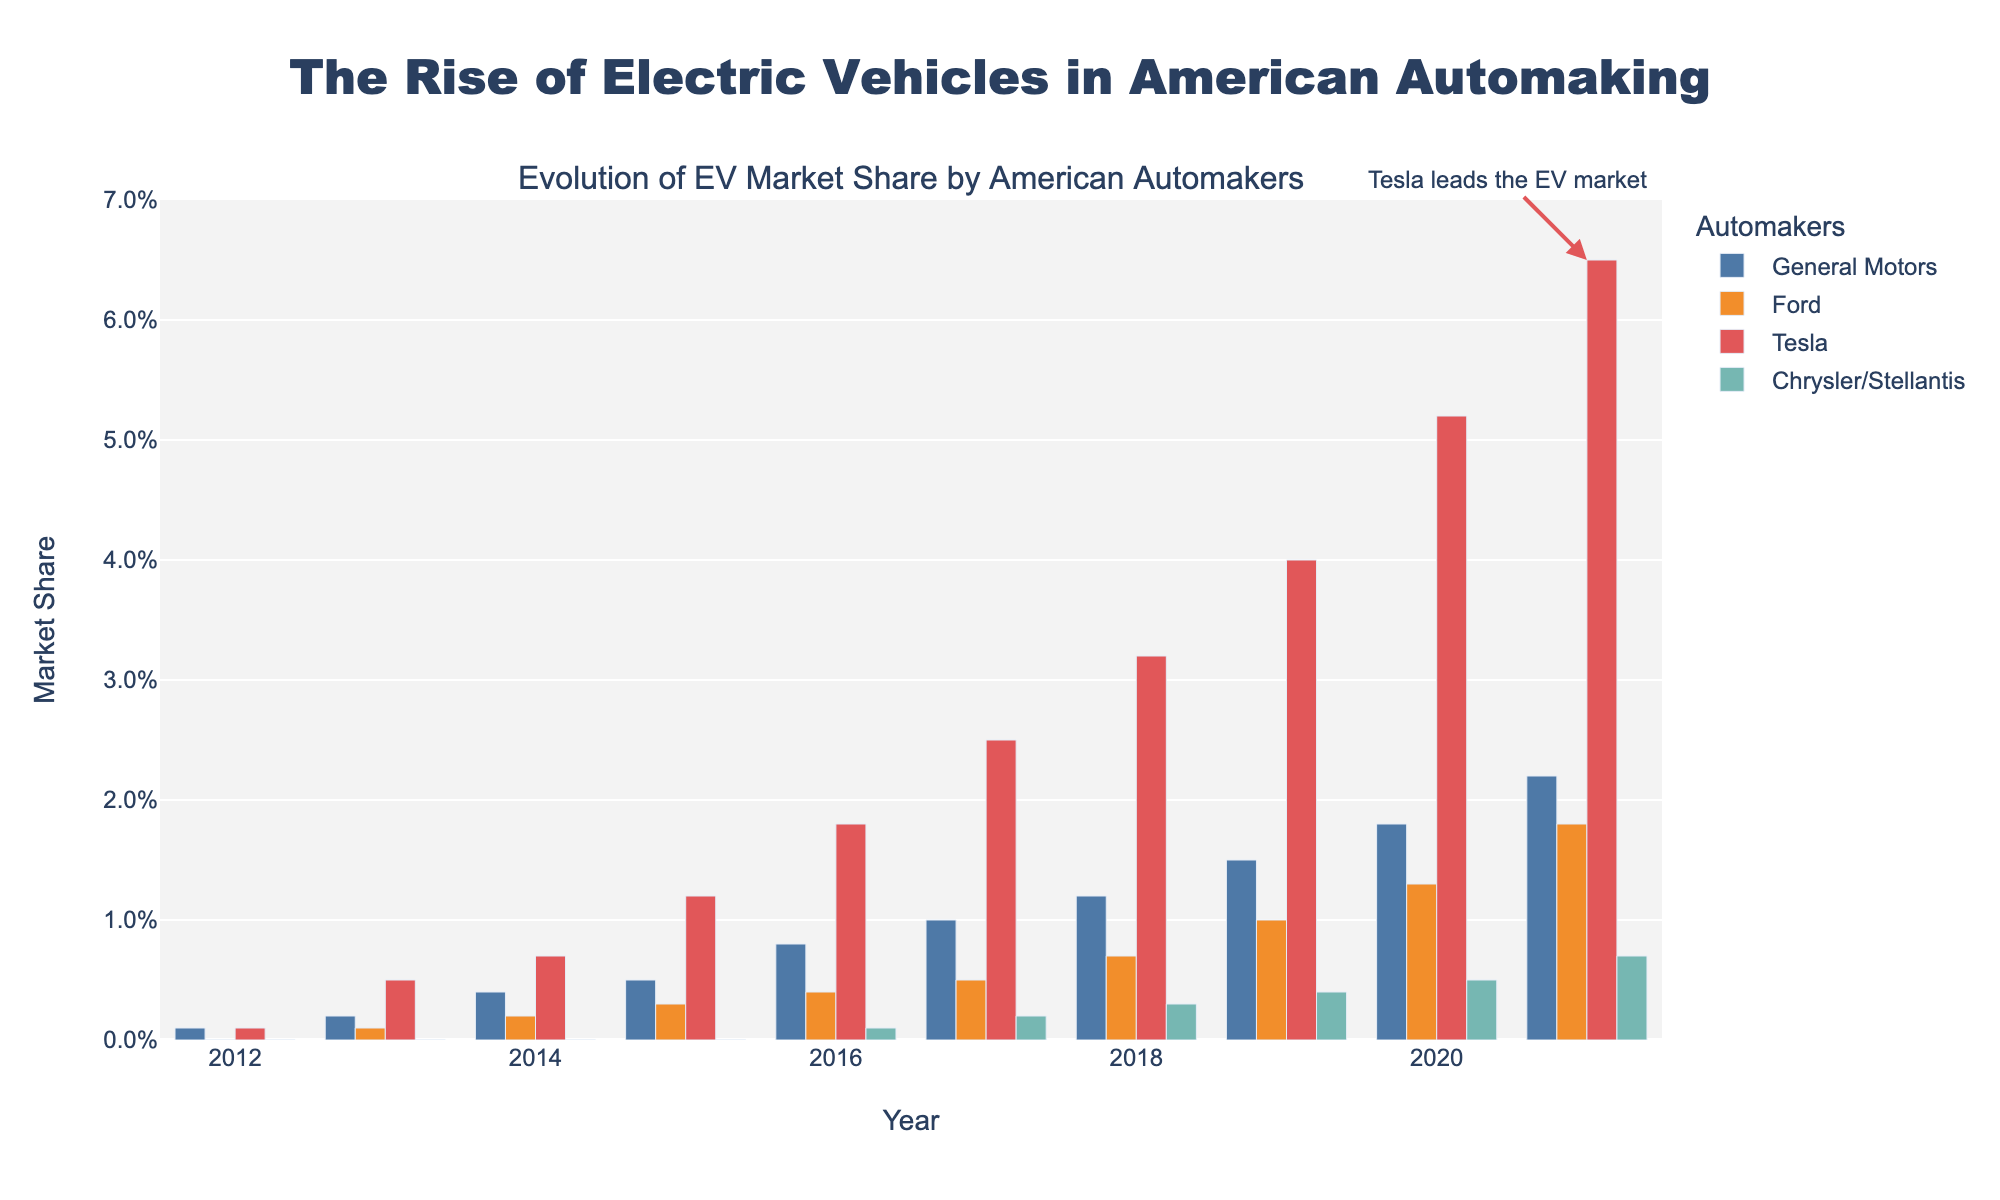How has Tesla's market share changed from 2012 to 2021? Tesla's market share starts at 0.1% in 2012 and increases each year, reaching 6.5% in 2021.
Answer: Tesla's share increased from 0.1% to 6.5% Which company shows the smallest market share increase over the decade? Comparing the delta in market share for each company: GM increased from 0.1% to 2.2%, Ford from 0% to 1.8%, Tesla from 0.1% to 6.5%, and Chrysler/Stellantis from 0% to 0.7%, Chrysler/Stellantis shows the smallest increase.
Answer: Chrysler/Stellantis Which year did Ford first surpass a 1% market share? Looking at Ford's data, the market share is 1.0% in 2019.
Answer: 2019 Which automakers have continuous growth throughout the decade? By inspecting the bar heights for each company across years, we see consistent growth for GM, Ford, and Tesla, while Chrysler/Stellantis has growth starting from 2016.
Answer: GM, Ford, Tesla Between 2015 and 2020, which companies doubled their market share? General Motors went from 0.5% to 1.8%, Ford from 0.3% to 1.3%, and Tesla from 1.2% to 5.2%. Only General Motors and Tesla had a significant increase that surpassed double.
Answer: General Motors, Tesla What is the combined market share for all four companies in 2021? Summing up the market shares for GM (2.2%), Ford (1.8%), Tesla (6.5%), and Chrysler/Stellantis (0.7%), we get 2.2% + 1.8% + 6.5% + 0.7% = 11.2%.
Answer: 11.2% Which automaker’s market share never goes beyond 1% in any year? By inspecting the bars, only Chrysler/Stellantis consistently stays below 1% throughout all years.
Answer: Chrysler/Stellantis How does the bar color help identify the automakers in this figure? Each automaker has a distinct color: General Motors is blue, Ford is orange, Tesla is red, and Chrysler/Stellantis is green.
Answer: Unique colors for each automaker Comparing 2014 and 2015, did all companies show an increase in market share? By comparing the bar heights for these two years, all companies—GM, Ford, and Tesla—show an increase, while Chrysler/Stellantis remains at 0.0%.
Answer: No Between 2016 and 2020, which year shows the highest total market share for all companies combined? Summing up the market shares for each year between 2016 and 2020: In 2020, the total is 1.8% + 1.3% + 5.2% + 0.5% = 8.8%, which is the highest.
Answer: 2020 